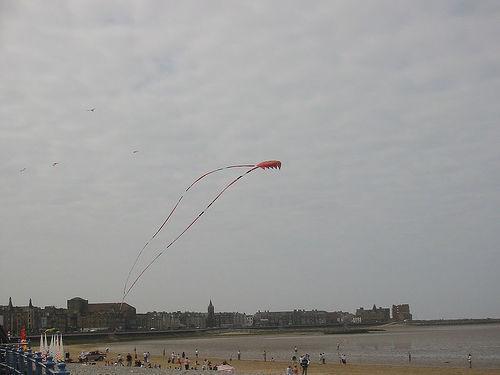How many kites are there?
Give a very brief answer. 1. 